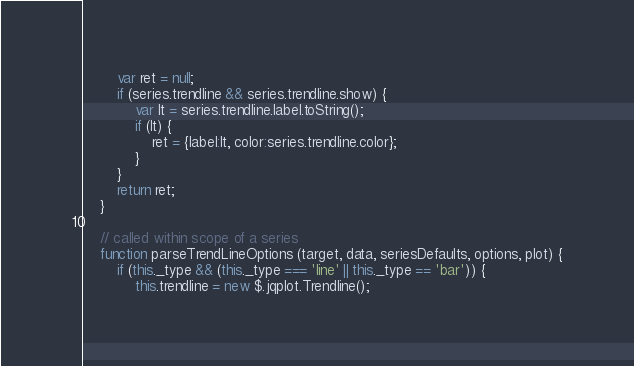Convert code to text. <code><loc_0><loc_0><loc_500><loc_500><_JavaScript_>        var ret = null;
        if (series.trendline && series.trendline.show) {
            var lt = series.trendline.label.toString();
            if (lt) {
                ret = {label:lt, color:series.trendline.color};
            }
        }
        return ret;
    }

    // called within scope of a series
    function parseTrendLineOptions (target, data, seriesDefaults, options, plot) {
        if (this._type && (this._type === 'line' || this._type == 'bar')) {
            this.trendline = new $.jqplot.Trendline();</code> 